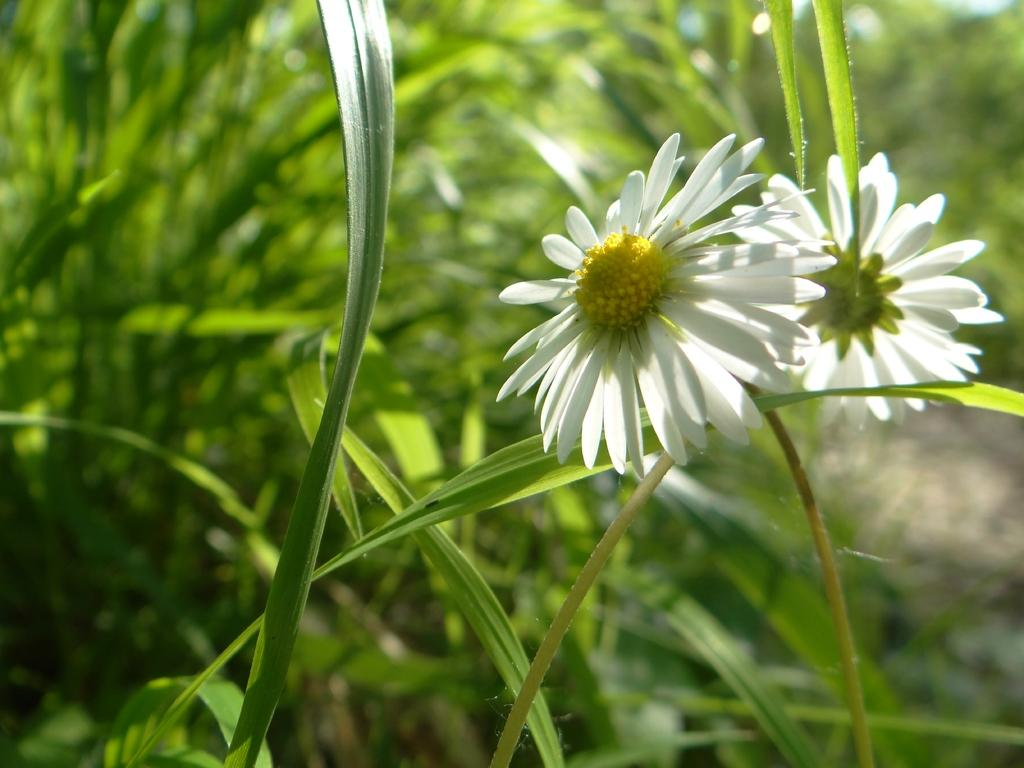What type of living organisms can be seen in the image? Plants can be seen in the image. What specific features are present on the plants? The plants have flowers, and the flowers are white in color. What is the color of the leaves and stems on the plants? The leaves and stems are green in color. What type of hall can be seen in the image? There is no hall present in the image; it features plants with white flowers and green leaves and stems. What kind of grain is visible in the image? There is no grain present in the image; it features plants with white flowers and green leaves and stems. 